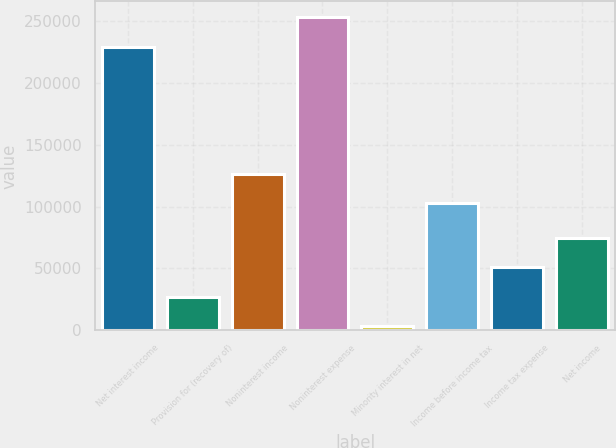<chart> <loc_0><loc_0><loc_500><loc_500><bar_chart><fcel>Net interest income<fcel>Provision for (recovery of)<fcel>Noninterest income<fcel>Noninterest expense<fcel>Minority interest in net<fcel>Income before income tax<fcel>Income tax expense<fcel>Net income<nl><fcel>229477<fcel>26964<fcel>126494<fcel>253351<fcel>3090<fcel>102620<fcel>50838<fcel>74712<nl></chart> 